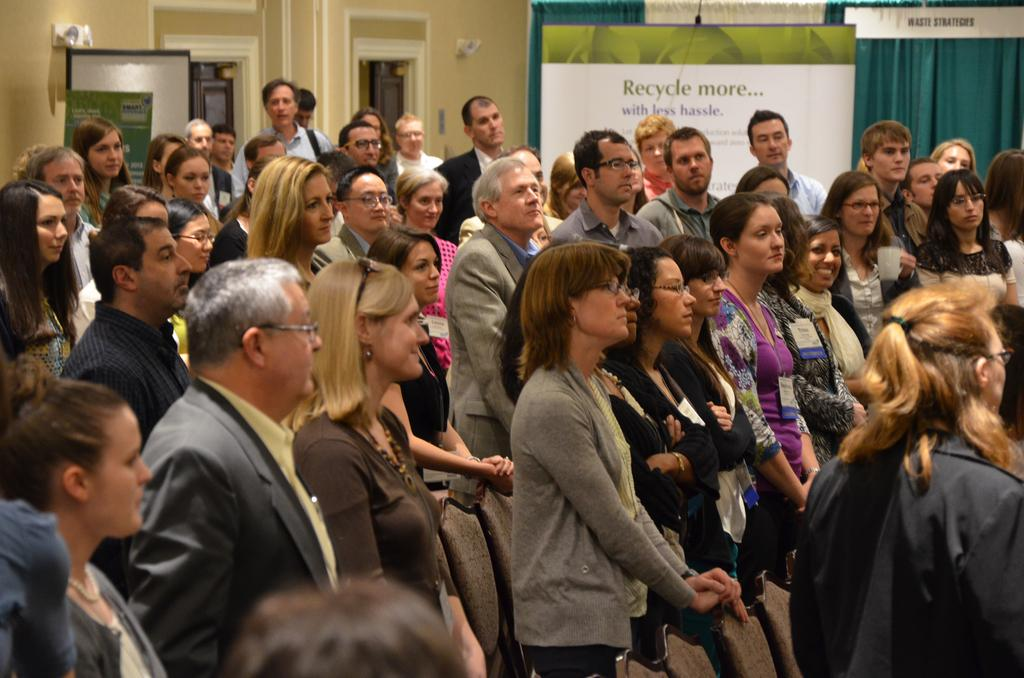How many people are visible in the image? There are many people standing in the image. What can be seen hanging in the image? There are banners in the image. What type of fabric is present in the image? There are curtains in the image. What architectural features can be seen in the image? There are doorways in the image. How many stems are visible in the image? There is no mention of stems in the provided facts, so we cannot determine the number of stems in the image. 